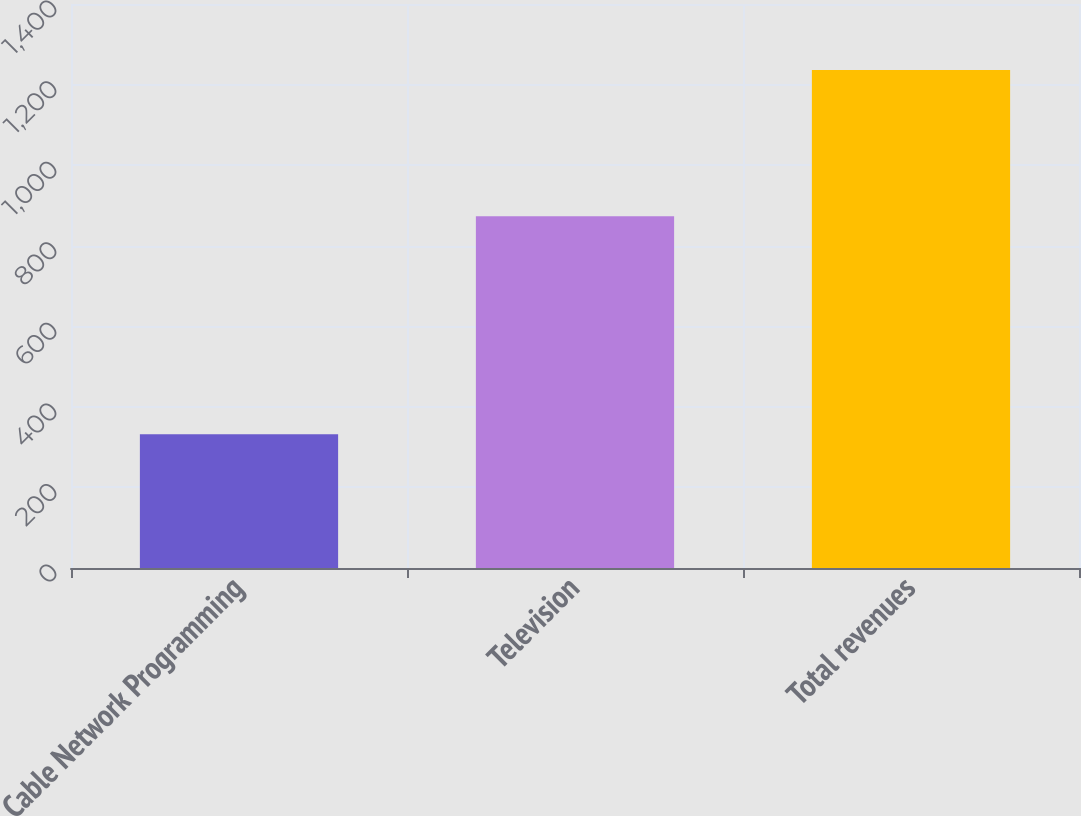Convert chart. <chart><loc_0><loc_0><loc_500><loc_500><bar_chart><fcel>Cable Network Programming<fcel>Television<fcel>Total revenues<nl><fcel>332<fcel>873<fcel>1236<nl></chart> 